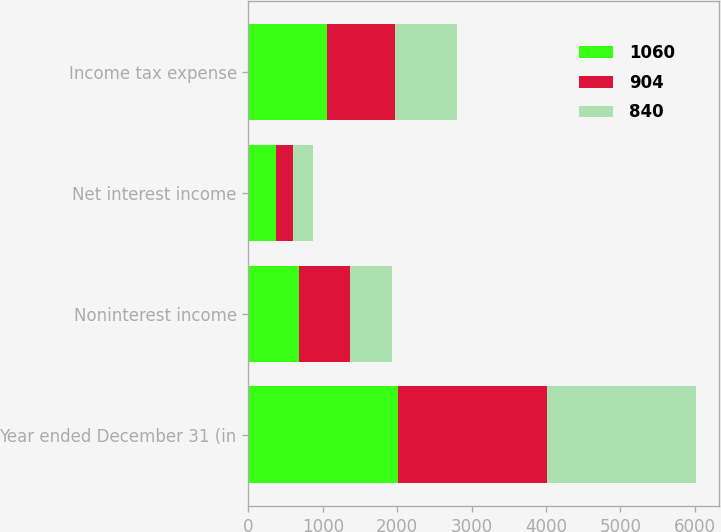<chart> <loc_0><loc_0><loc_500><loc_500><stacked_bar_chart><ecel><fcel>Year ended December 31 (in<fcel>Noninterest income<fcel>Net interest income<fcel>Income tax expense<nl><fcel>1060<fcel>2007<fcel>683<fcel>377<fcel>1060<nl><fcel>904<fcel>2006<fcel>676<fcel>228<fcel>904<nl><fcel>840<fcel>2005<fcel>571<fcel>269<fcel>840<nl></chart> 